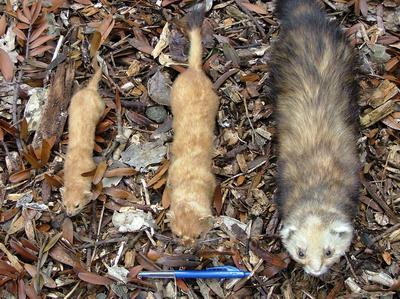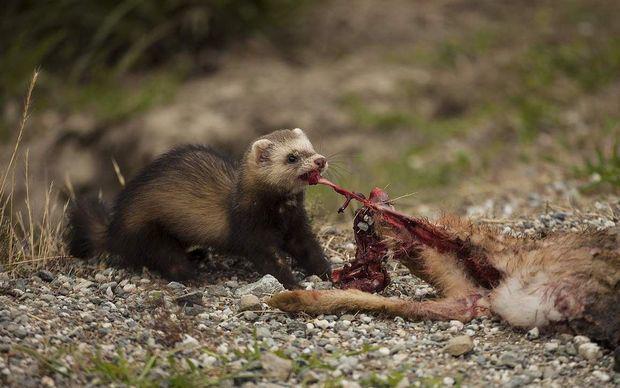The first image is the image on the left, the second image is the image on the right. Assess this claim about the two images: "Three animals are stretched out of the leaves in one of the images.". Correct or not? Answer yes or no. Yes. The first image is the image on the left, the second image is the image on the right. Evaluate the accuracy of this statement regarding the images: "An image shows a row of exactly three ferret-like animals of different sizes.". Is it true? Answer yes or no. Yes. 